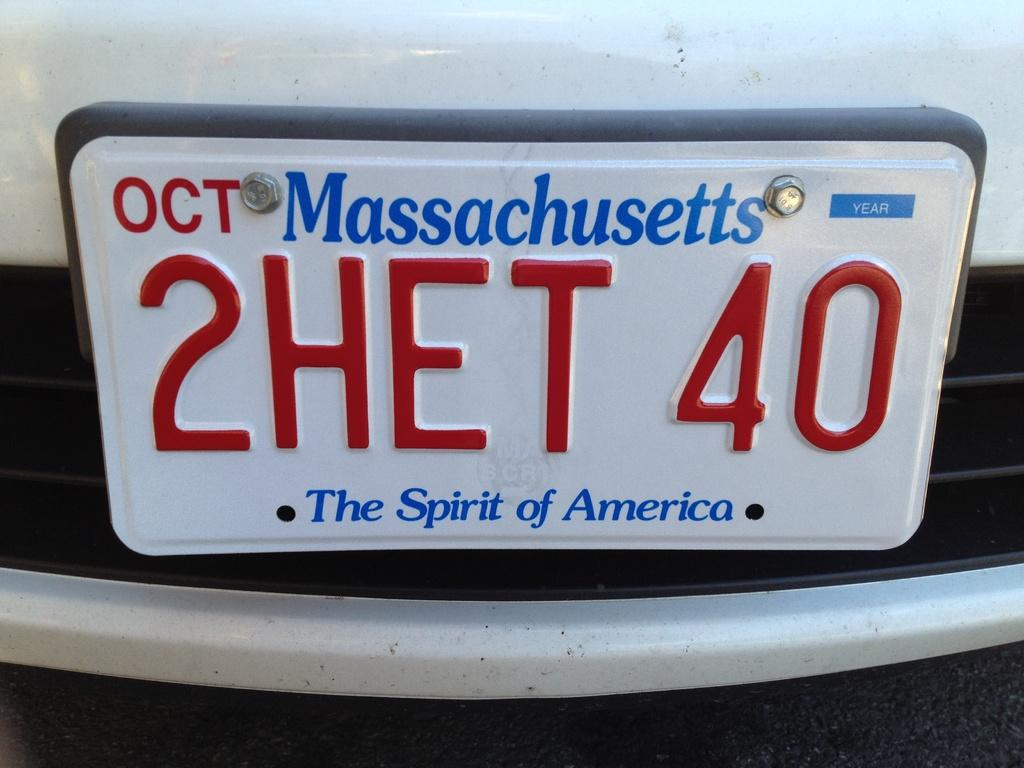Provide a one-sentence caption for the provided image. A license plate of a car coming from Massachusetts. 